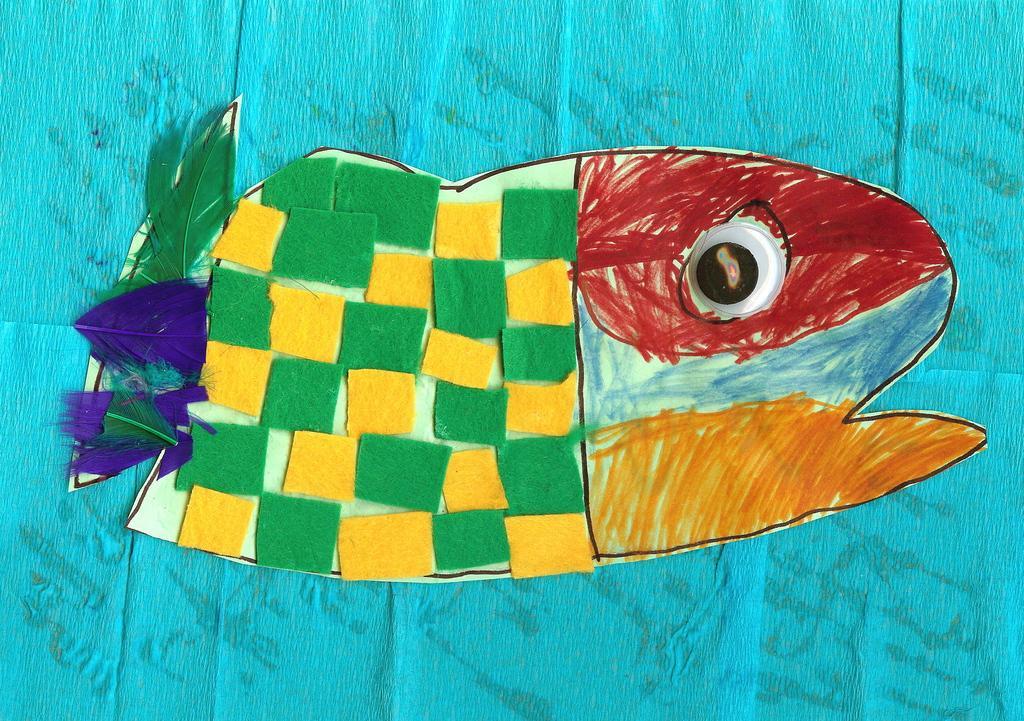Describe this image in one or two sentences. In this picture I can see the paper art of a fish, on an object. 